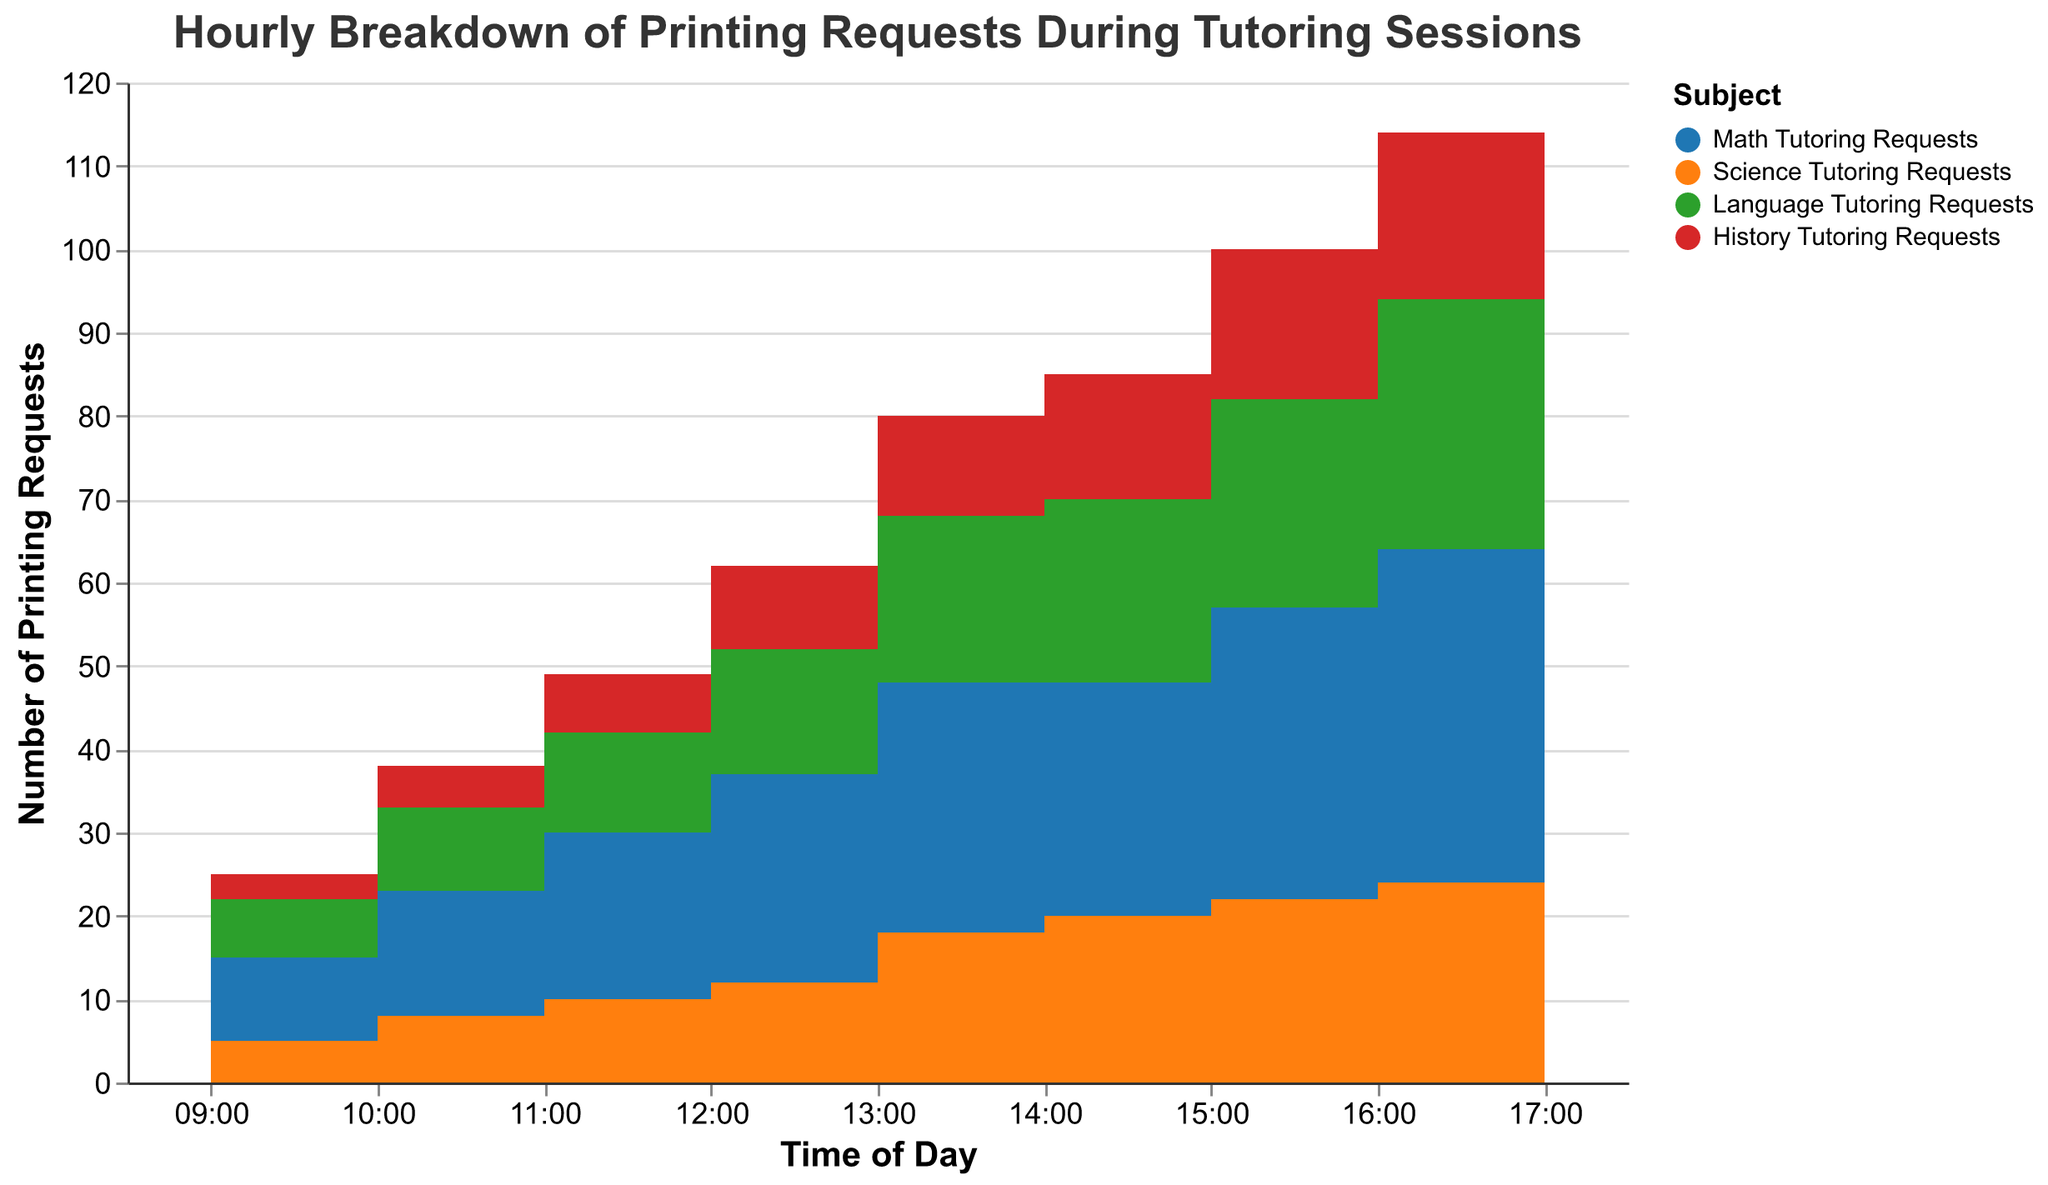What's the highest number of printing requests for Math Tutoring in a single hour? By observing the stacked step area chart, the highest value for Math Tutoring Requests is at 16:00, where it reaches 40 requests.
Answer: 40 During which hour are Science Tutoring printing requests the highest? From the chart, the peak of the Science Tutoring Requests is at 16:00 with a value of 24 requests.
Answer: 16:00 Which subject has the least number of printing requests at 11:00? At 11:00, History Tutoring Requests have the fewest requests with only 7 requests, as indicated by the chart.
Answer: History What's the total number of printing requests across all subjects at 10:00? Adding up the requests at 10:00 for all subjects: Math (15) + Science (8) + Language (10) + History (5) = 38 requests in total.
Answer: 38 How do the printing requests for Language Tutoring change from 09:00 to 17:00? The Language Tutoring Requests start at 7 at 09:00, then increase consistently until they reach their peak at 16:00 with 30 requests, and finally decrease slightly to 27 at 17:00.
Answer: Increase, then slight decrease Which subject shows the most significant increase in requests from 14:00 to 16:00? Between 14:00 and 16:00, Math Tutoring requests increase from 28 to 40, which is a 12-request increase, the highest among the subjects.
Answer: Math How do the Science Tutoring printing requests compare to History at 14:00? At 14:00, the Science Tutoring Requests are 20, while the History Tutoring Requests are 15. This shows that Science is 5 more than History.
Answer: Science is 5 more What time shows the steepest increase in Math Tutoring requests? The sharpest increase in Math Tutoring Requests is from 09:00 to 10:00 and from 12:00 to 13:00, with each interval showing a 10-request jump.
Answer: Both 09:00-10:00 and 12:00-13:00 Which two subjects combined have the same number of requests as Math Tutoring at 15:00? At 15:00, Math Tutoring Requests are 35. Adding Science (22) and History (18), their combined total is 40 which is closer. Alternatively, combining Language (25) and History (18) gives us exactly 43 which is mathematically closer than the combined alternative.
Answer: Language and History 